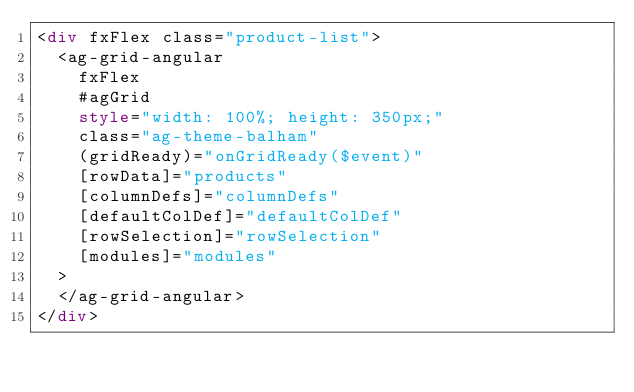<code> <loc_0><loc_0><loc_500><loc_500><_HTML_><div fxFlex class="product-list">
  <ag-grid-angular
    fxFlex
    #agGrid
    style="width: 100%; height: 350px;"
    class="ag-theme-balham"
    (gridReady)="onGridReady($event)"
    [rowData]="products"
    [columnDefs]="columnDefs"
    [defaultColDef]="defaultColDef"
    [rowSelection]="rowSelection"
    [modules]="modules"
  >
  </ag-grid-angular>
</div>
</code> 